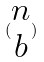<formula> <loc_0><loc_0><loc_500><loc_500>( \begin{matrix} n \\ b \end{matrix} )</formula> 